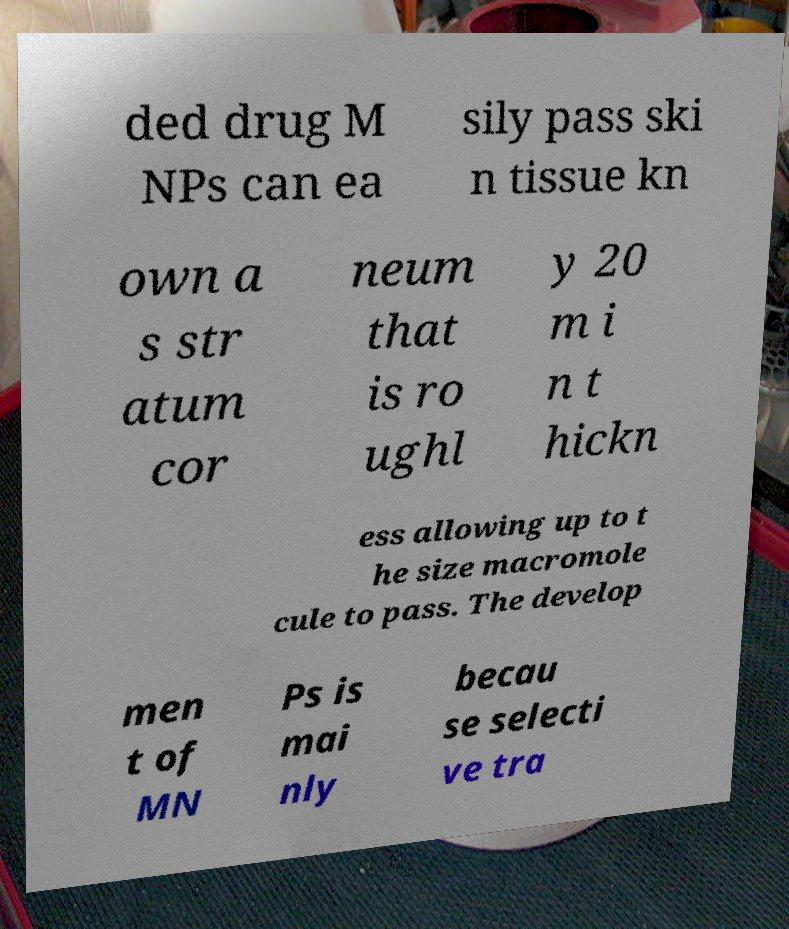I need the written content from this picture converted into text. Can you do that? ded drug M NPs can ea sily pass ski n tissue kn own a s str atum cor neum that is ro ughl y 20 m i n t hickn ess allowing up to t he size macromole cule to pass. The develop men t of MN Ps is mai nly becau se selecti ve tra 